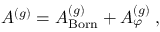Convert formula to latex. <formula><loc_0><loc_0><loc_500><loc_500>A ^ { ( g ) } = A _ { B o r n } ^ { ( g ) } + A _ { \varphi } ^ { ( g ) } \, ,</formula> 